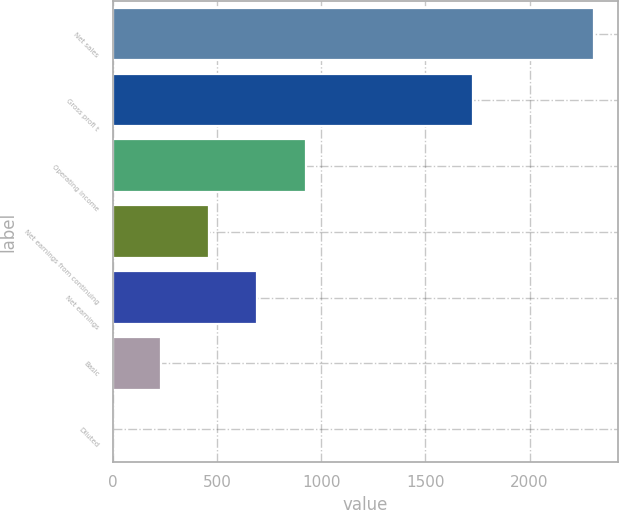<chart> <loc_0><loc_0><loc_500><loc_500><bar_chart><fcel>Net sales<fcel>Gross profi t<fcel>Operating income<fcel>Net earnings from continuing<fcel>Net earnings<fcel>Basic<fcel>Diluted<nl><fcel>2308.8<fcel>1730.3<fcel>924.22<fcel>462.68<fcel>693.45<fcel>231.91<fcel>1.14<nl></chart> 